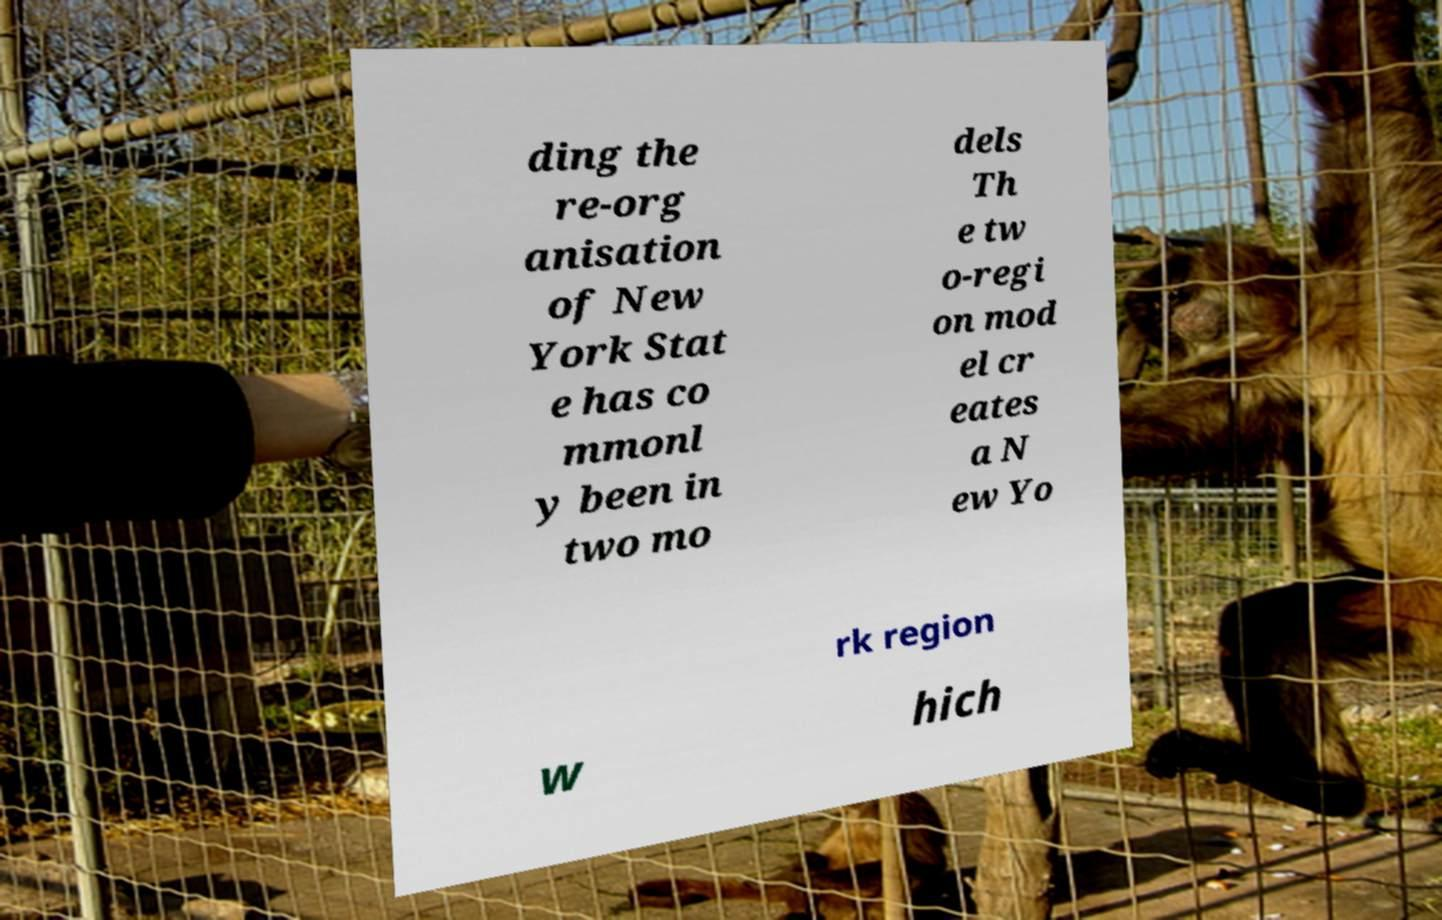Can you accurately transcribe the text from the provided image for me? ding the re-org anisation of New York Stat e has co mmonl y been in two mo dels Th e tw o-regi on mod el cr eates a N ew Yo rk region w hich 